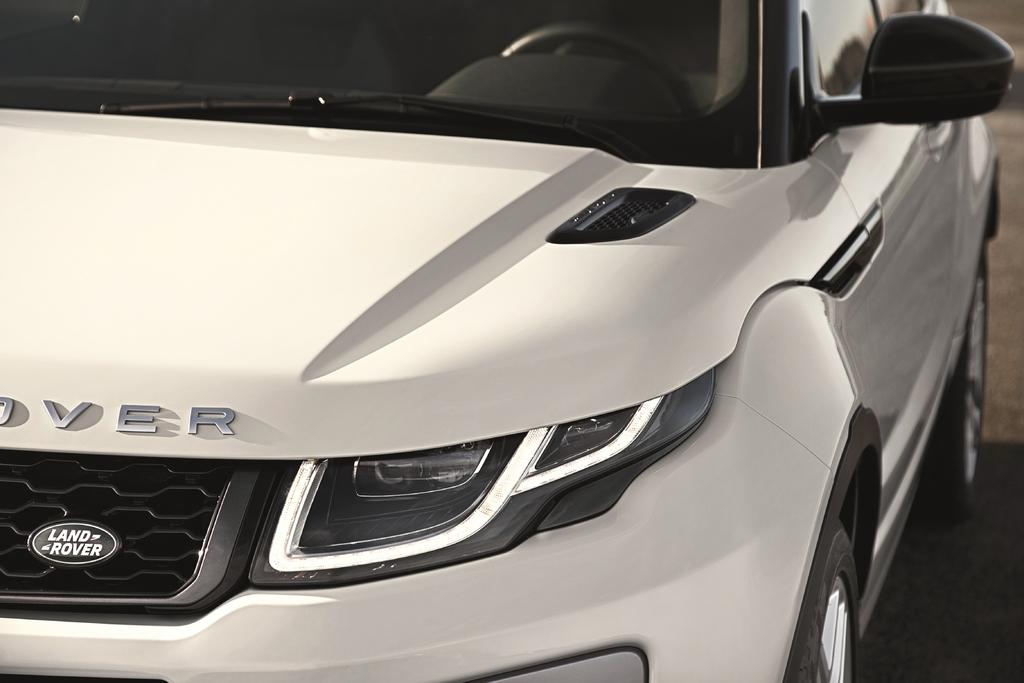What type of vehicle is present in the image? There is a motor vehicle in the image. How many dogs are playing the game on the beam in the image? There are no dogs or beams present in the image; it features a motor vehicle. 